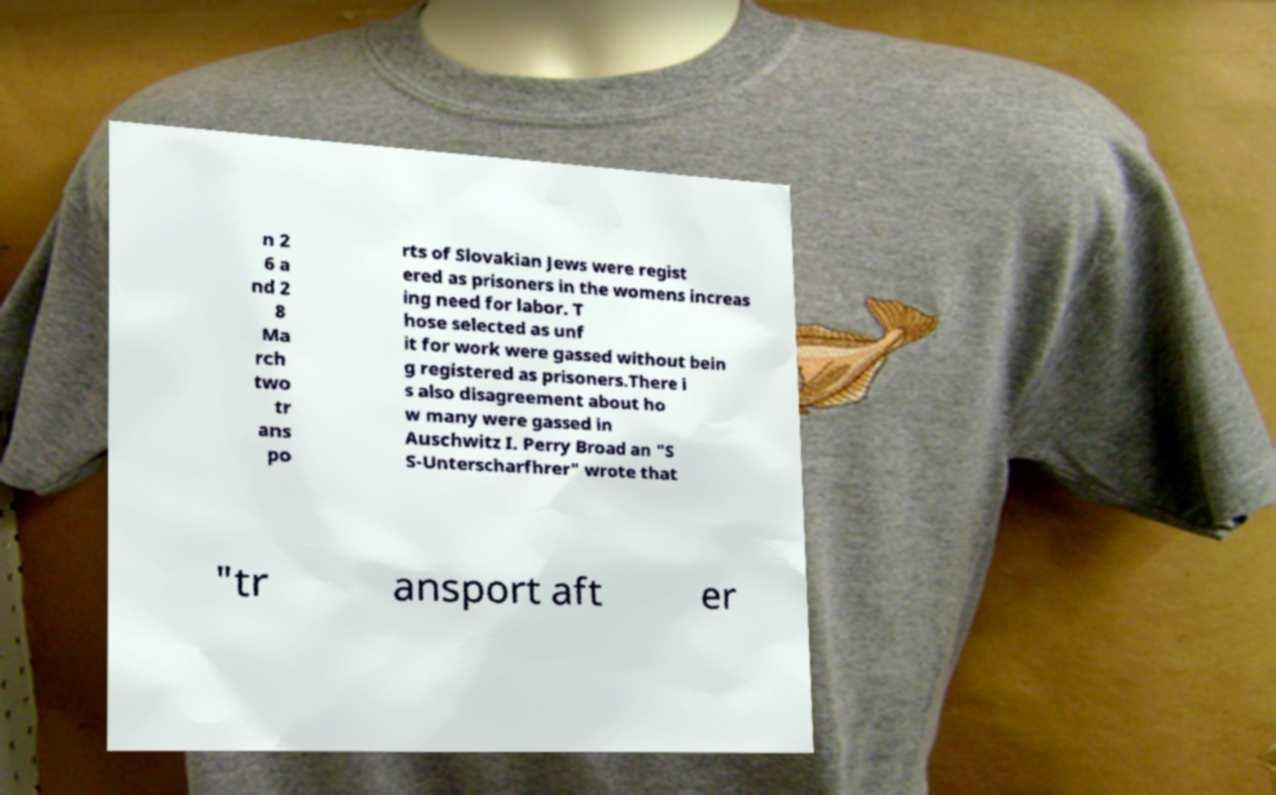Can you accurately transcribe the text from the provided image for me? n 2 6 a nd 2 8 Ma rch two tr ans po rts of Slovakian Jews were regist ered as prisoners in the womens increas ing need for labor. T hose selected as unf it for work were gassed without bein g registered as prisoners.There i s also disagreement about ho w many were gassed in Auschwitz I. Perry Broad an "S S-Unterscharfhrer" wrote that "tr ansport aft er 